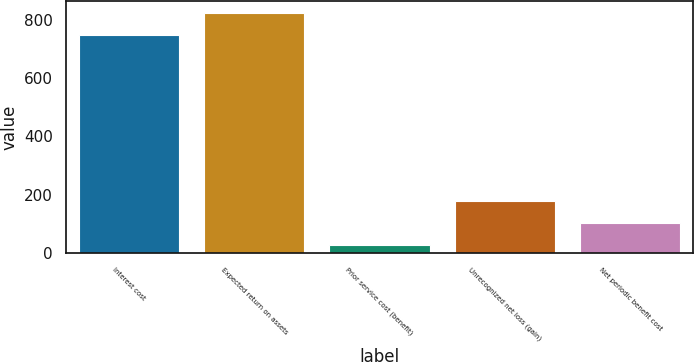Convert chart. <chart><loc_0><loc_0><loc_500><loc_500><bar_chart><fcel>Interest cost<fcel>Expected return on assets<fcel>Prior service cost (benefit)<fcel>Unrecognized net loss (gain)<fcel>Net periodic benefit cost<nl><fcel>746<fcel>821.8<fcel>28<fcel>179.6<fcel>103.8<nl></chart> 